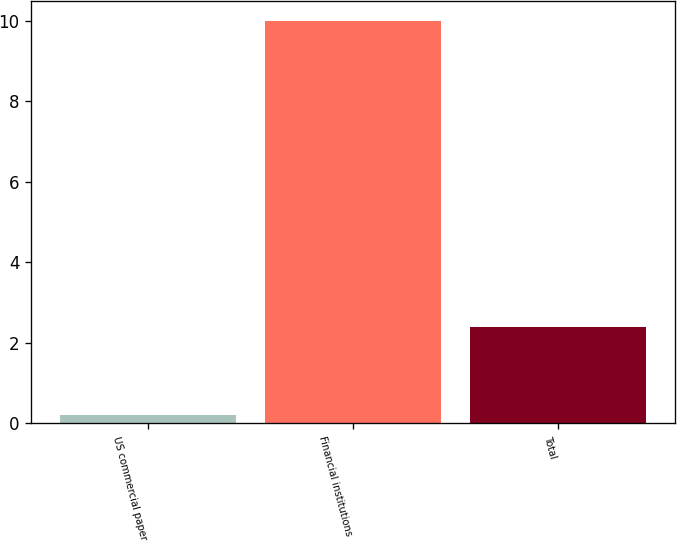Convert chart. <chart><loc_0><loc_0><loc_500><loc_500><bar_chart><fcel>US commercial paper<fcel>Financial institutions<fcel>Total<nl><fcel>0.2<fcel>10<fcel>2.4<nl></chart> 